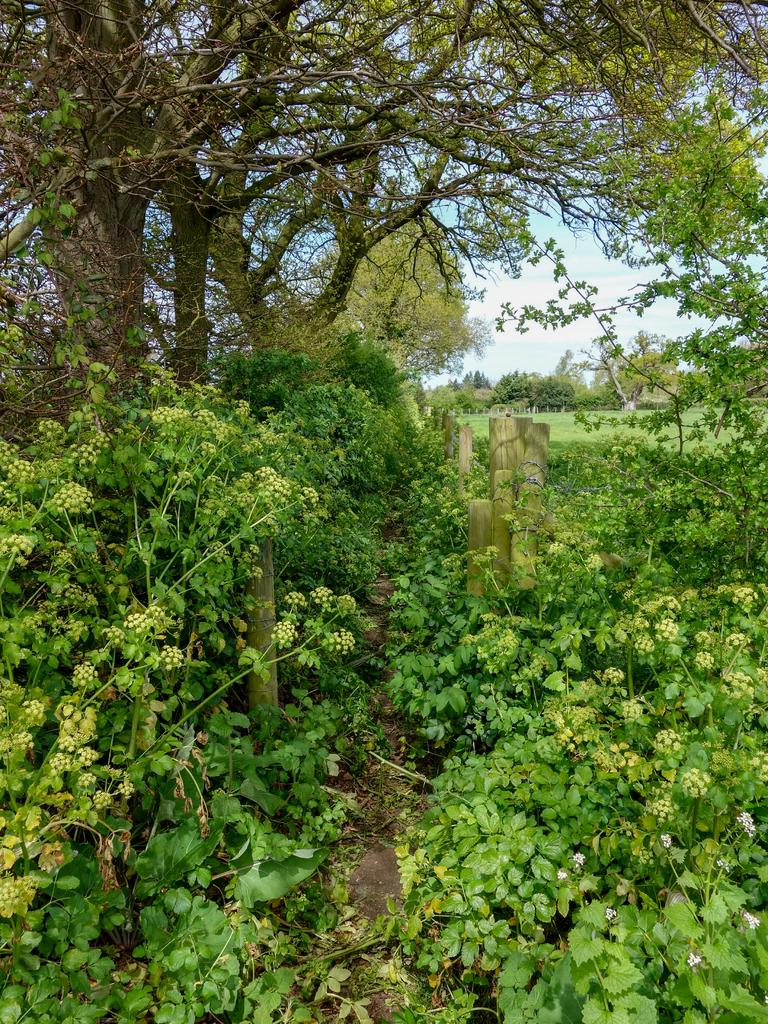What type of vegetation is present in the image? There is a group of plants and trees in the image. What can be seen in the background of the image? The sky is visible in the background of the image. What type of feast is being held in the image? There is no feast present in the image; it features a group of plants and trees with the sky visible in the background. 